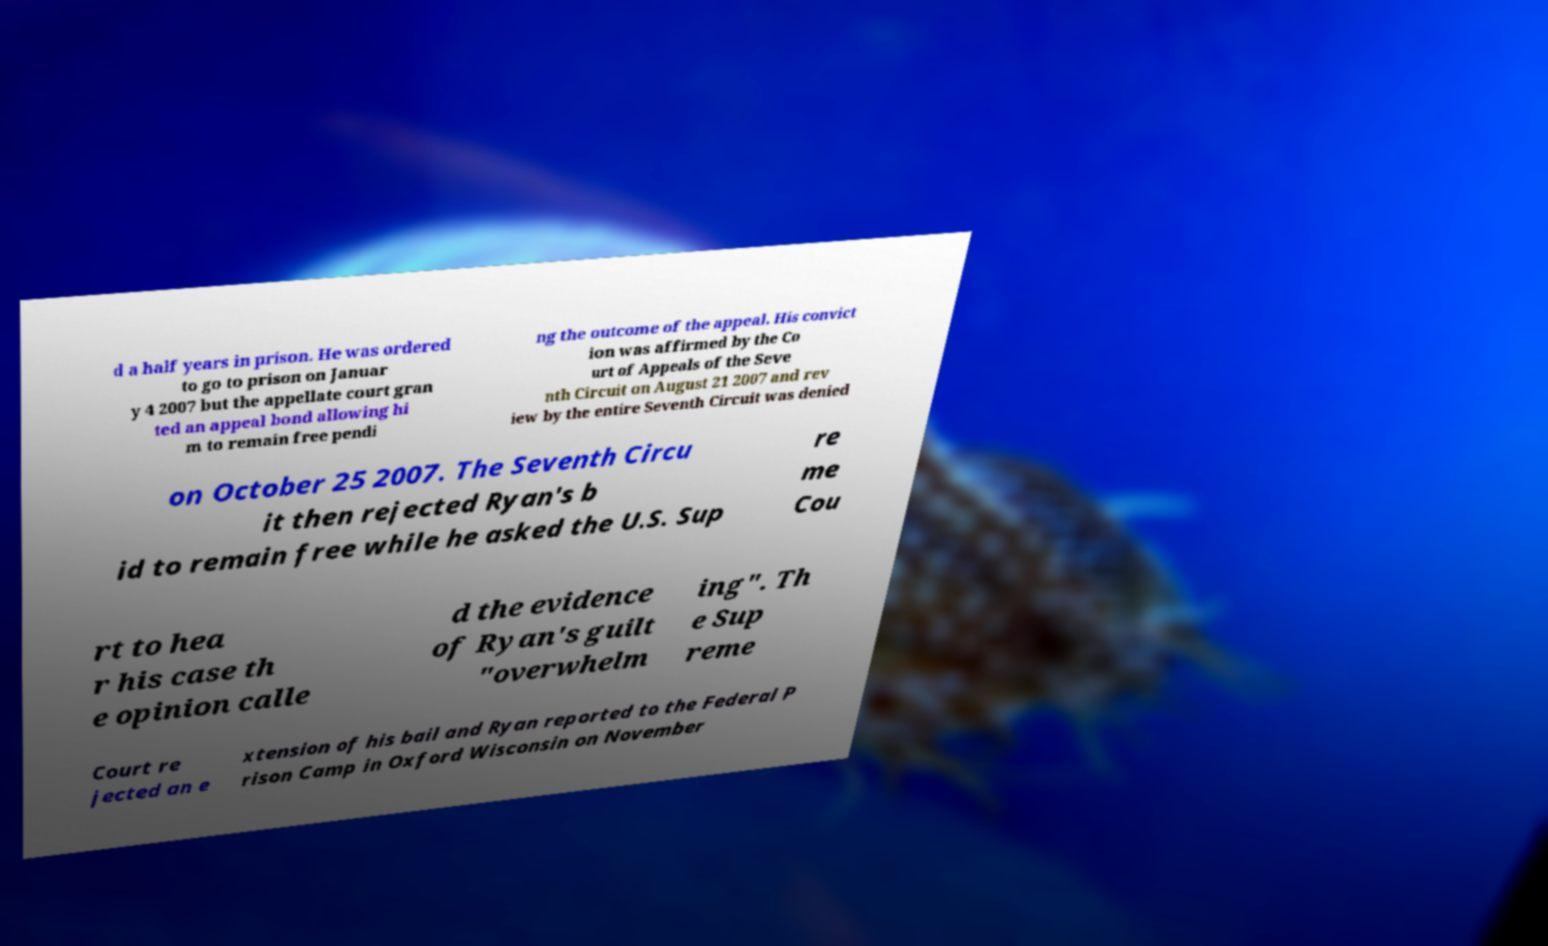For documentation purposes, I need the text within this image transcribed. Could you provide that? d a half years in prison. He was ordered to go to prison on Januar y 4 2007 but the appellate court gran ted an appeal bond allowing hi m to remain free pendi ng the outcome of the appeal. His convict ion was affirmed by the Co urt of Appeals of the Seve nth Circuit on August 21 2007 and rev iew by the entire Seventh Circuit was denied on October 25 2007. The Seventh Circu it then rejected Ryan's b id to remain free while he asked the U.S. Sup re me Cou rt to hea r his case th e opinion calle d the evidence of Ryan's guilt "overwhelm ing". Th e Sup reme Court re jected an e xtension of his bail and Ryan reported to the Federal P rison Camp in Oxford Wisconsin on November 